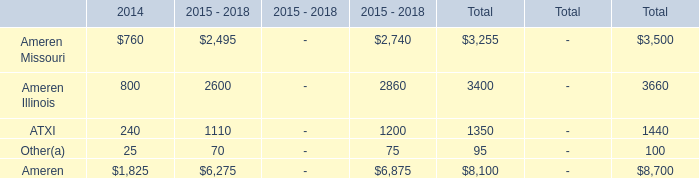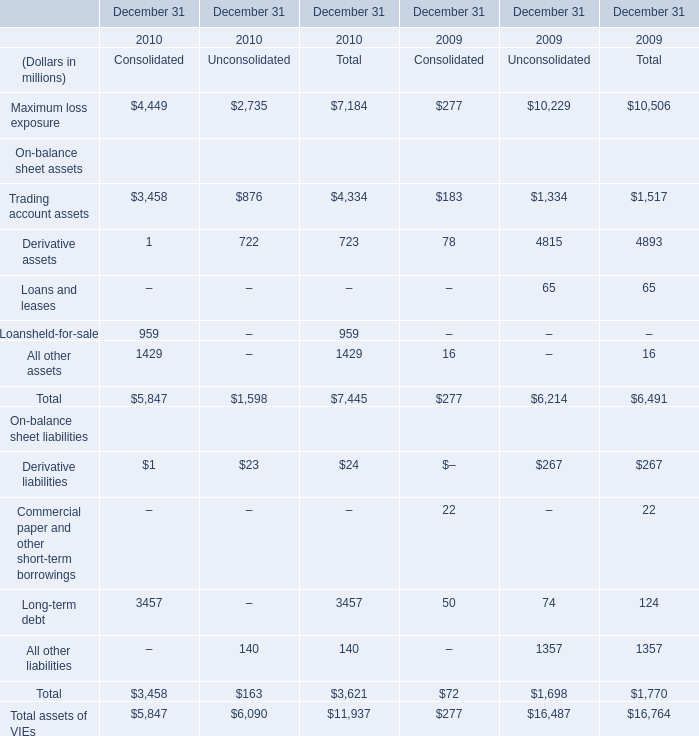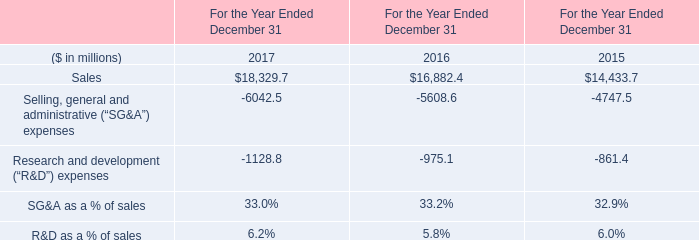What's the sum of Sales of For the Year Ended December 31 2016, and Maximum loss exposure of December 31 2010 Unconsolidated ? 
Computations: (16882.4 + 2735.0)
Answer: 19617.4. 